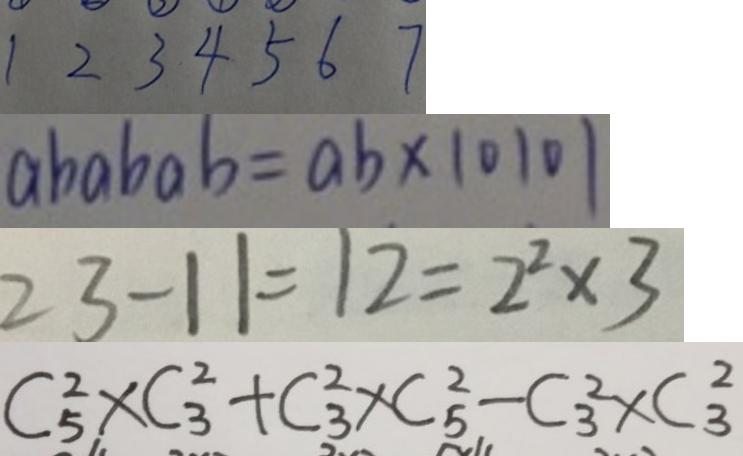Convert formula to latex. <formula><loc_0><loc_0><loc_500><loc_500>1 2 3 4 5 6 7 
 a b a b a b = a b \times 1 0 1 0 1 
 2 3 - 1 1 = 1 2 = 2 ^ { 2 } \times 3 
 C _ { 5 } ^ { 2 } \times C _ { 3 } ^ { 2 } + C _ { 3 } ^ { 2 } \times C _ { 5 } ^ { 2 } - C _ { 3 } ^ { 2 } \times C _ { 3 } ^ { 2 }</formula> 